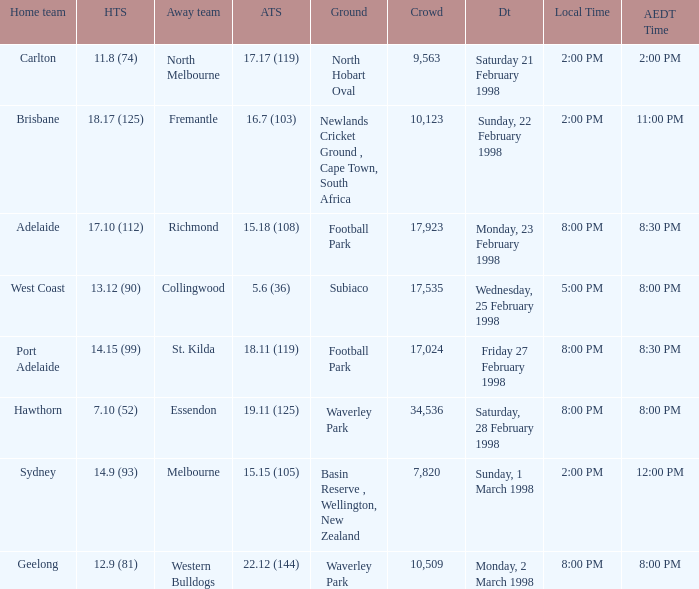Name the AEDT Time which has an Away team of collingwood? 8:00 PM. 